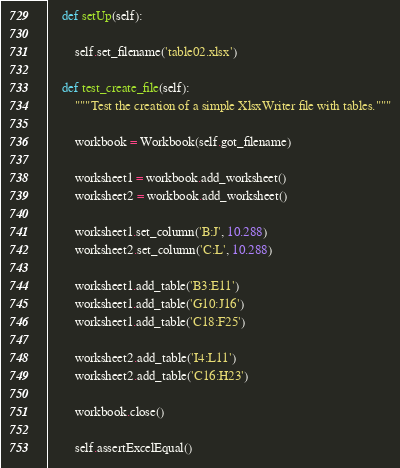Convert code to text. <code><loc_0><loc_0><loc_500><loc_500><_Python_>
    def setUp(self):

        self.set_filename('table02.xlsx')

    def test_create_file(self):
        """Test the creation of a simple XlsxWriter file with tables."""

        workbook = Workbook(self.got_filename)

        worksheet1 = workbook.add_worksheet()
        worksheet2 = workbook.add_worksheet()

        worksheet1.set_column('B:J', 10.288)
        worksheet2.set_column('C:L', 10.288)

        worksheet1.add_table('B3:E11')
        worksheet1.add_table('G10:J16')
        worksheet1.add_table('C18:F25')

        worksheet2.add_table('I4:L11')
        worksheet2.add_table('C16:H23')

        workbook.close()

        self.assertExcelEqual()
</code> 